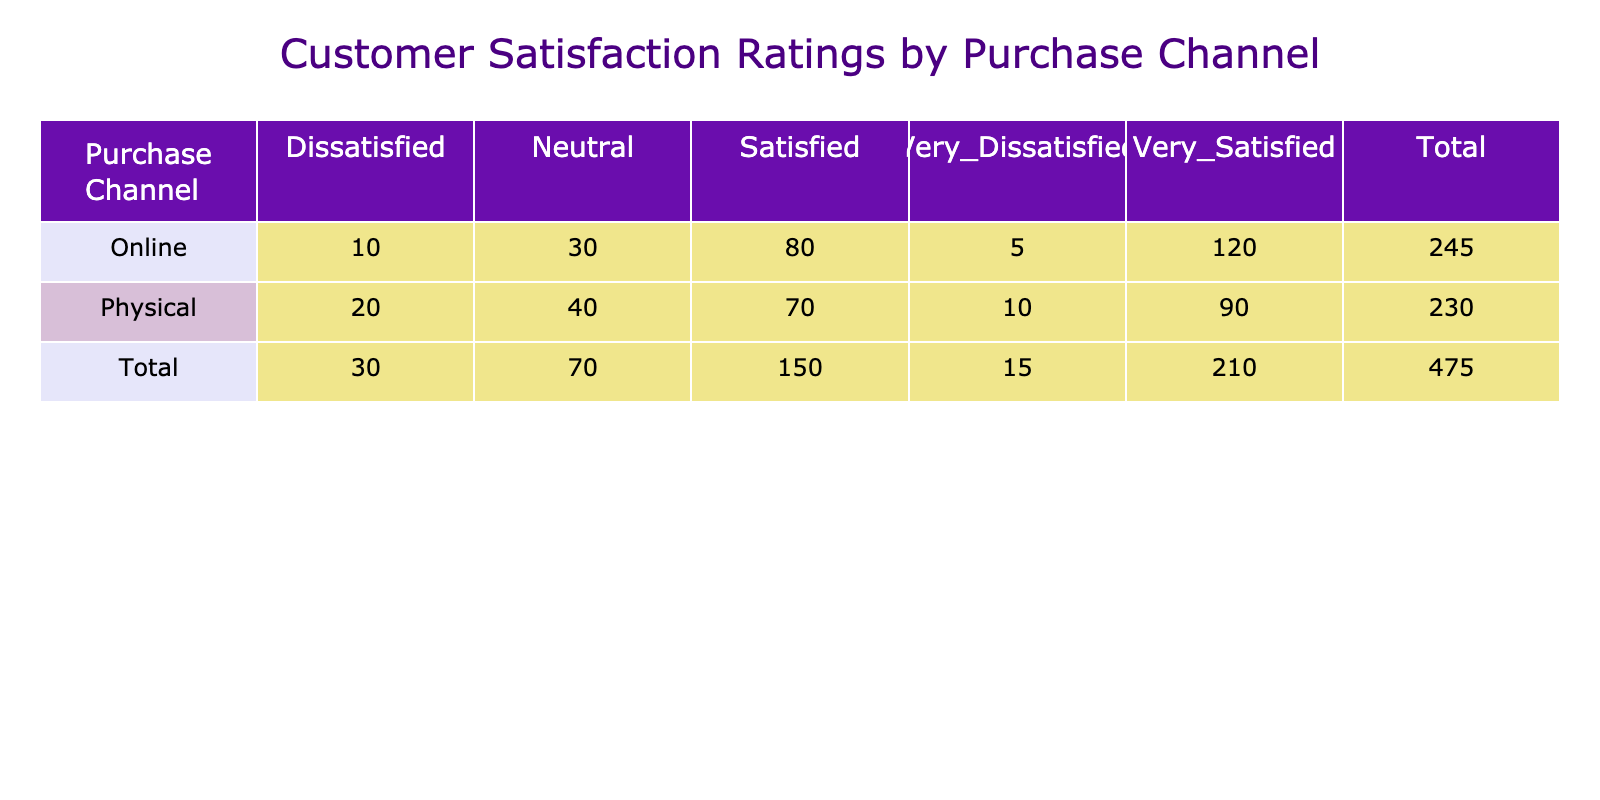What is the total number of customers who were very satisfied with the online purchase channel? From the table, for the online purchase channel, the number of customers who rated as "Very Satisfied" is listed as 120. Therefore, the total number of customers who were very satisfied with the online purchase channel is 120.
Answer: 120 How many customers are dissatisfied or very dissatisfied in the physical purchase channel? In the physical purchase channel, the numbers for "Dissatisfied" and "Very Dissatisfied" are 20 and 10, respectively. Adding these two values gives: 20 + 10 = 30. Thus, the total number of customers who are dissatisfied or very dissatisfied in the physical purchase channel is 30.
Answer: 30 Did more customers report being "Satisfied" in the online or physical purchase channel? For the online channel, the number of "Satisfied" customers is 80. For the physical channel, the same rating has 70 customers. Since 80 (online) is greater than 70 (physical), more customers reported being "Satisfied" in the online purchase channel.
Answer: Yes What is the difference in the total number of very satisfied customers between online and physical purchase channels? The number of "Very Satisfied" customers for online is 120, and for physical, it is 90. Taking the difference: 120 - 90 = 30. Therefore, the difference in the total number of very satisfied customers between the two channels is 30.
Answer: 30 What percentage of physical customers rated their satisfaction as Neutral? The total number of customers for the physical channel is: 90 (Very Satisfied) + 70 (Satisfied) + 40 (Neutral) + 20 (Dissatisfied) + 10 (Very Dissatisfied) = 230. The number of customers who rated their satisfaction as Neutral is 40. Therefore, the percentage is: (40 / 230) * 100 = approximately 17.39%.
Answer: 17.39% What is the total count of satisfied customers across both purchase channels? The count of "Satisfied" customers for the online channel is 80, and for the physical channel, it is 70. Summing these two gives: 80 + 70 = 150. Thus, the total count of satisfied customers across both channels is 150.
Answer: 150 Does the online purchase channel have a higher total number of ratings compared to the physical purchase channel? Summing the ratings for the online channel gives: 120 + 80 + 30 + 10 + 5 = 245, while for the physical channel: 90 + 70 + 40 + 20 + 10 = 230. Since 245 (online) is greater than 230 (physical), the online purchase channel has a higher total number of ratings.
Answer: Yes Which satisfaction rating has the highest count in physical purchase channel? Looking at the counts, "Very Satisfied" has the highest count of 90 in the physical channel compared to other ratings (Satisfied: 70, Neutral: 40, Dissatisfied: 20, Very Dissatisfied: 10). Thus, "Very Satisfied" has the highest count.
Answer: Very Satisfied 